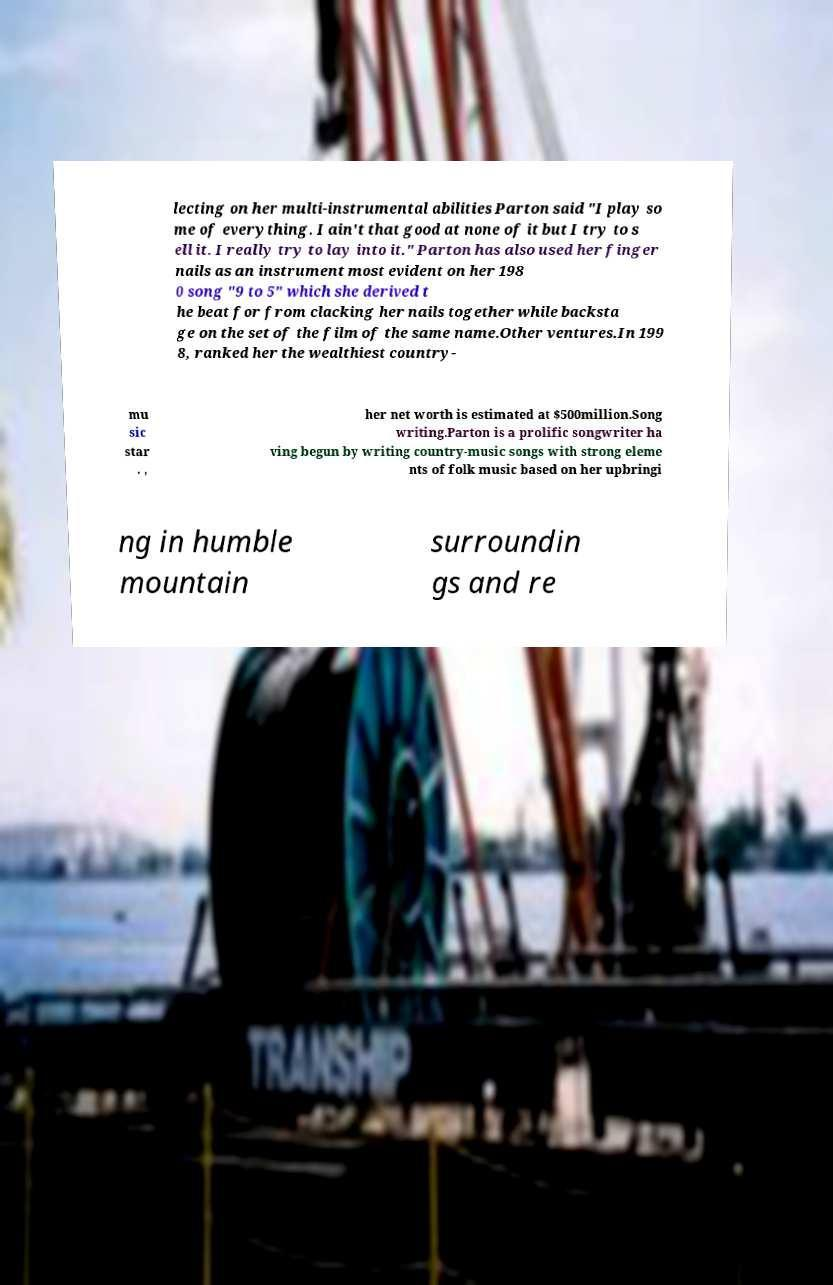Can you read and provide the text displayed in the image?This photo seems to have some interesting text. Can you extract and type it out for me? lecting on her multi-instrumental abilities Parton said "I play so me of everything. I ain't that good at none of it but I try to s ell it. I really try to lay into it." Parton has also used her finger nails as an instrument most evident on her 198 0 song "9 to 5" which she derived t he beat for from clacking her nails together while backsta ge on the set of the film of the same name.Other ventures.In 199 8, ranked her the wealthiest country- mu sic star . , her net worth is estimated at $500million.Song writing.Parton is a prolific songwriter ha ving begun by writing country-music songs with strong eleme nts of folk music based on her upbringi ng in humble mountain surroundin gs and re 